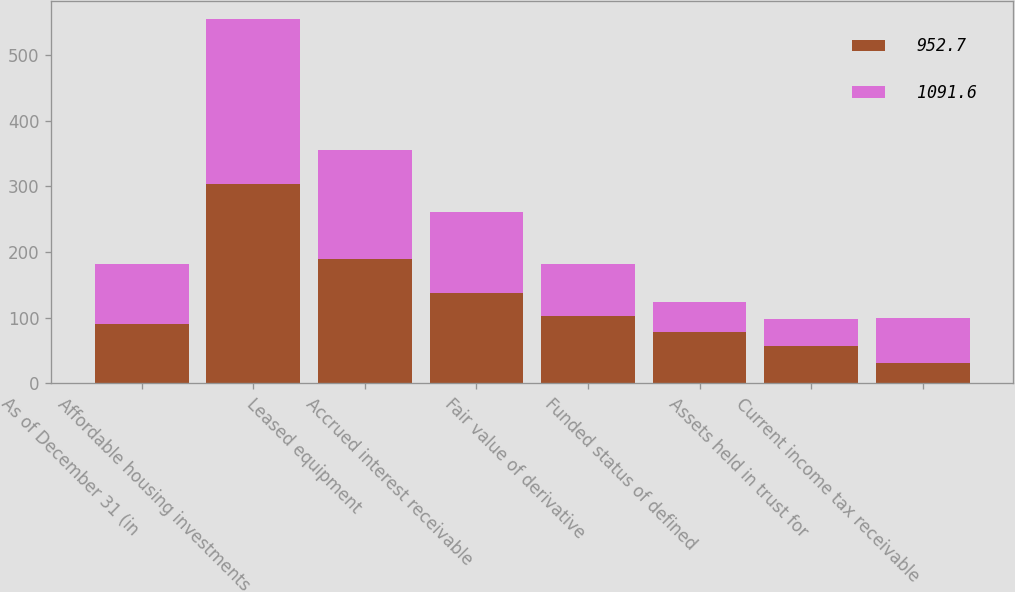<chart> <loc_0><loc_0><loc_500><loc_500><stacked_bar_chart><ecel><fcel>As of December 31 (in<fcel>Affordable housing investments<fcel>Leased equipment<fcel>Accrued interest receivable<fcel>Fair value of derivative<fcel>Funded status of defined<fcel>Assets held in trust for<fcel>Current income tax receivable<nl><fcel>952.7<fcel>90.5<fcel>304.1<fcel>189<fcel>138.2<fcel>103<fcel>78<fcel>56.4<fcel>31.4<nl><fcel>1091.6<fcel>90.5<fcel>250.7<fcel>165.8<fcel>122.9<fcel>77.9<fcel>46.4<fcel>41.3<fcel>68.7<nl></chart> 